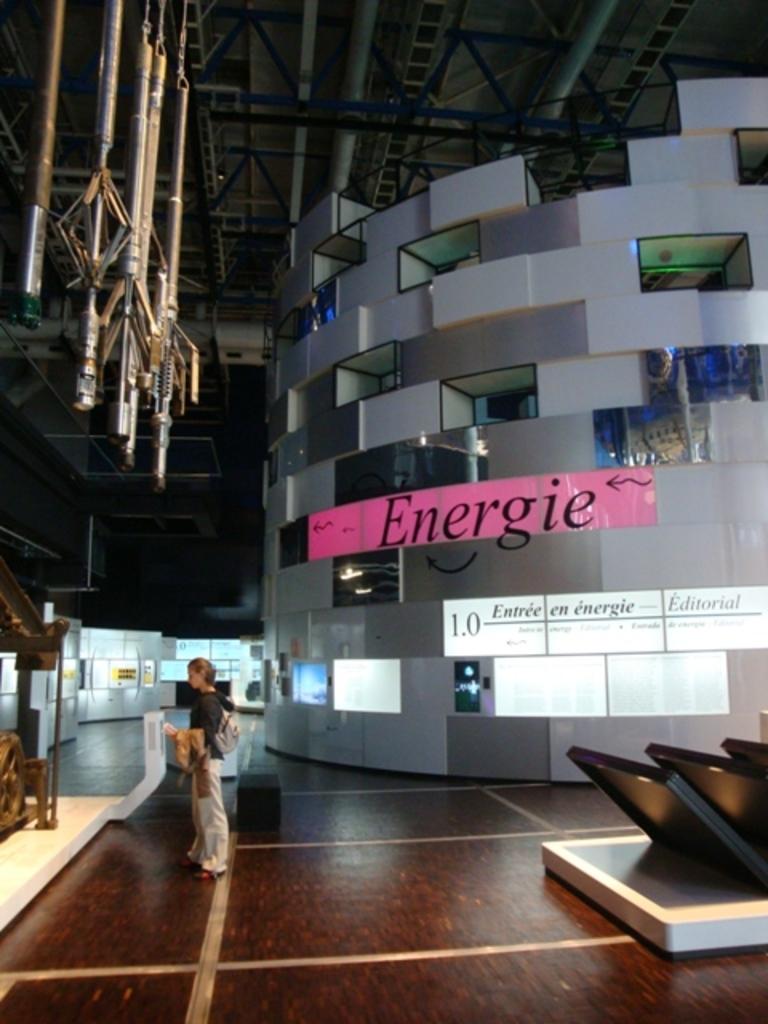What word is in the pink box?
Provide a short and direct response. Energie. What number is displayed in the white box?
Keep it short and to the point. 1.0. 